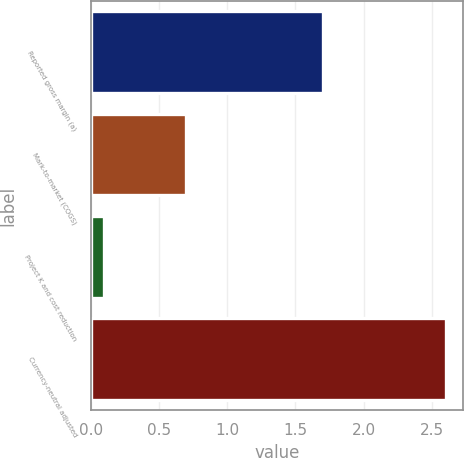Convert chart. <chart><loc_0><loc_0><loc_500><loc_500><bar_chart><fcel>Reported gross margin (a)<fcel>Mark-to-market (COGS)<fcel>Project K and cost reduction<fcel>Currency-neutral adjusted<nl><fcel>1.7<fcel>0.7<fcel>0.1<fcel>2.6<nl></chart> 